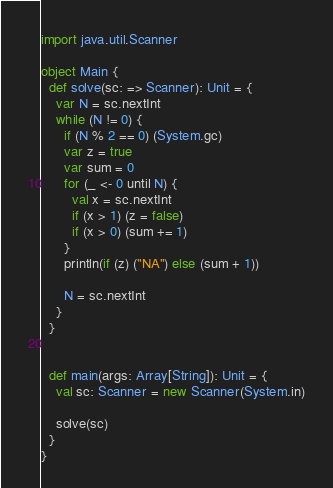Convert code to text. <code><loc_0><loc_0><loc_500><loc_500><_Scala_>import java.util.Scanner

object Main {
  def solve(sc: => Scanner): Unit = {
    var N = sc.nextInt
    while (N != 0) {
      if (N % 2 == 0) (System.gc)
      var z = true
      var sum = 0
      for (_ <- 0 until N) {
        val x = sc.nextInt
        if (x > 1) (z = false)
        if (x > 0) (sum += 1)
      }
      println(if (z) ("NA") else (sum + 1))

      N = sc.nextInt
    }
  }


  def main(args: Array[String]): Unit = {
    val sc: Scanner = new Scanner(System.in)

    solve(sc)
  }
}</code> 